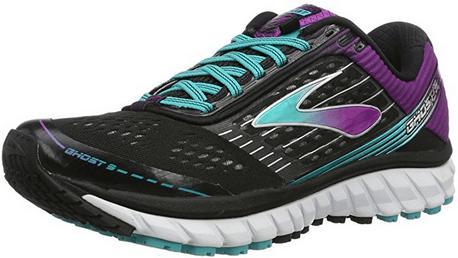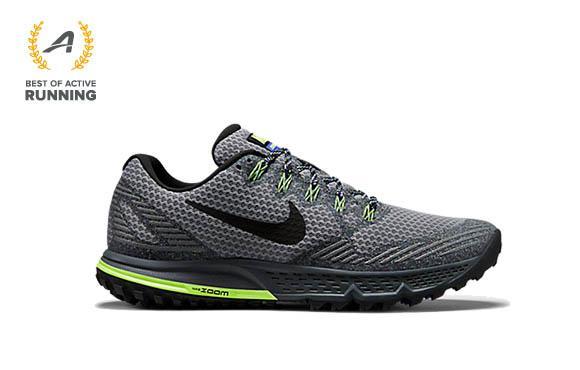The first image is the image on the left, the second image is the image on the right. Examine the images to the left and right. Is the description "Both shoes are pointing to the right." accurate? Answer yes or no. No. The first image is the image on the left, the second image is the image on the right. Evaluate the accuracy of this statement regarding the images: "Each image contains one right-facing shoe with bright colored treads on the bottom of the sole.". Is it true? Answer yes or no. No. 